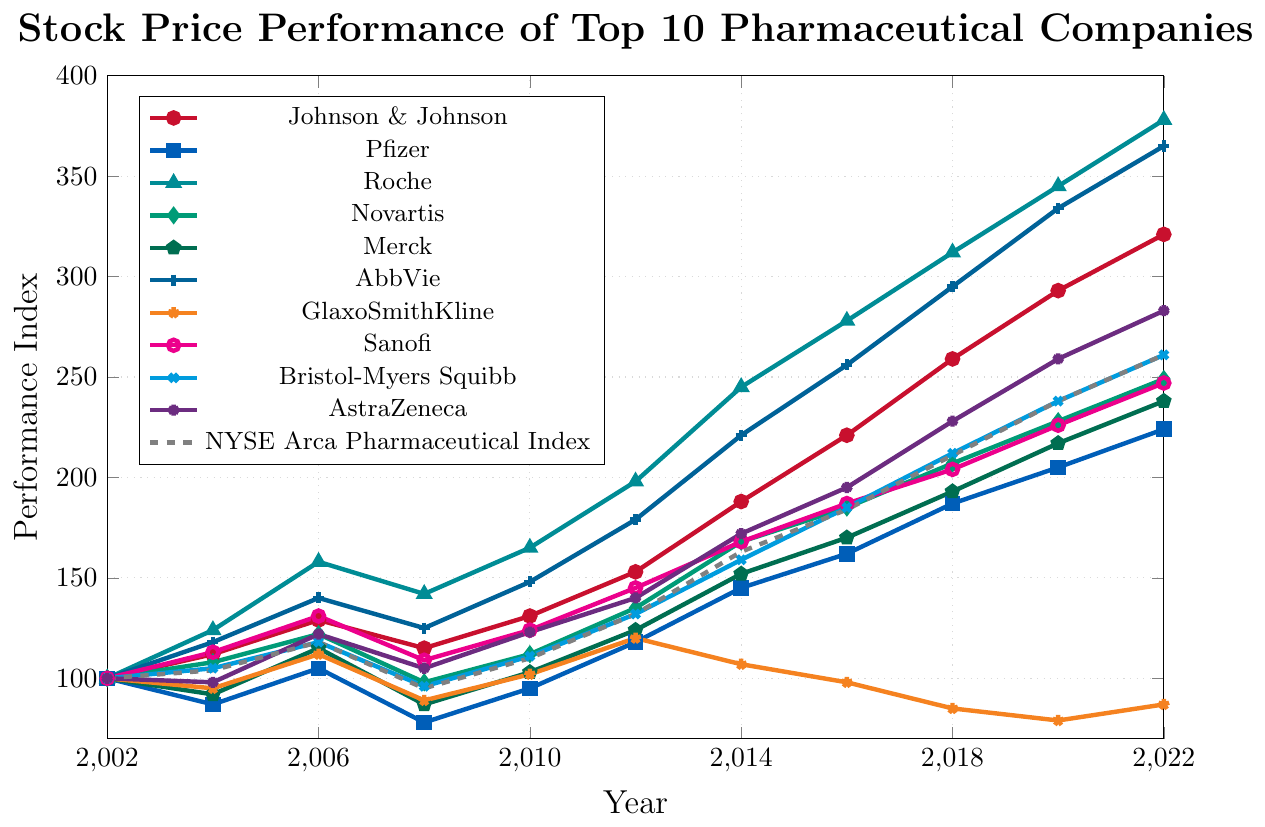Comparing the stock price performance of Johnson & Johnson and Pfizer in 2010, which company performed better? First, locate the points for Johnson & Johnson and Pfizer in 2010 on the graph. Johnson & Johnson is at 131, and Pfizer is at 95. 131 is greater than 95, so Johnson & Johnson performed better.
Answer: Johnson & Johnson Which company's stock price performance showed the greatest increase between 2002 and 2022? Examine the final and initial data points for all companies. Roche's stock moved from 100 in 2002 to 378 in 2022. Calculate the difference: 378 - 100 = 278, which is the greatest increase among all companies.
Answer: Roche How did GlaxoSmithKline's performance in 2022 compare to its performance in 2008? Locate GlaxoSmithKline's points for 2022 and 2008. In 2022, it is at 87, and in 2008, it is at 89. Since 87 is slightly lower than 89, the performance slightly decreased.
Answer: Slightly decreased What is the average stock price performance of Sanofi from 2006 to 2012? Identify Sanofi’s values for 2006, 2008, 2010, and 2012, which are 131, 109, 124, and 145 respectively. Add these values: 131 + 109 + 124 + 145 = 509. Divide by the number of data points, which is 4. The average is 509/4 = 127.25.
Answer: 127.25 Which company had the lowest performance in 2020? Find all the values for 2020, then identify the lowest one. GlaxoSmithKline is at 79 in 2020, which is the lowest.
Answer: GlaxoSmithKline Between Merck and AbbVie, whose stock performance exceeded the industry index more frequently from 2002 to 2022? Compare the performance of Merck and AbbVie against the NYSE Arca Pharmaceutical Index from 2002 to 2022. Merck exceeds the index in 2004, 2006, 2012, 2014, 2016, 2018, 2020, and 2022 (8 times), whereas AbbVie exceeds the index in 2004, 2006, 2010, 2012, 2014, 2016, 2018, 2020, and 2022 (9 times).
Answer: AbbVie How did the performance index of the NYSE Arca Pharmaceutical Index change from 2010 to 2020? Find the points for the NYSE Arca Pharmaceutical Index in 2010 (110) and 2020 (238), then calculate the difference: 238 - 110 = 128. The performance index increased by 128.
Answer: Increased by 128 Identify a company with a consistent upward trend in stock performance over the 20 years. Look for a line that steadily increases from 2002 to 2022 without a major dip. Johnson & Johnson shows a consistent upward trend without notable declines.
Answer: Johnson & Johnson 